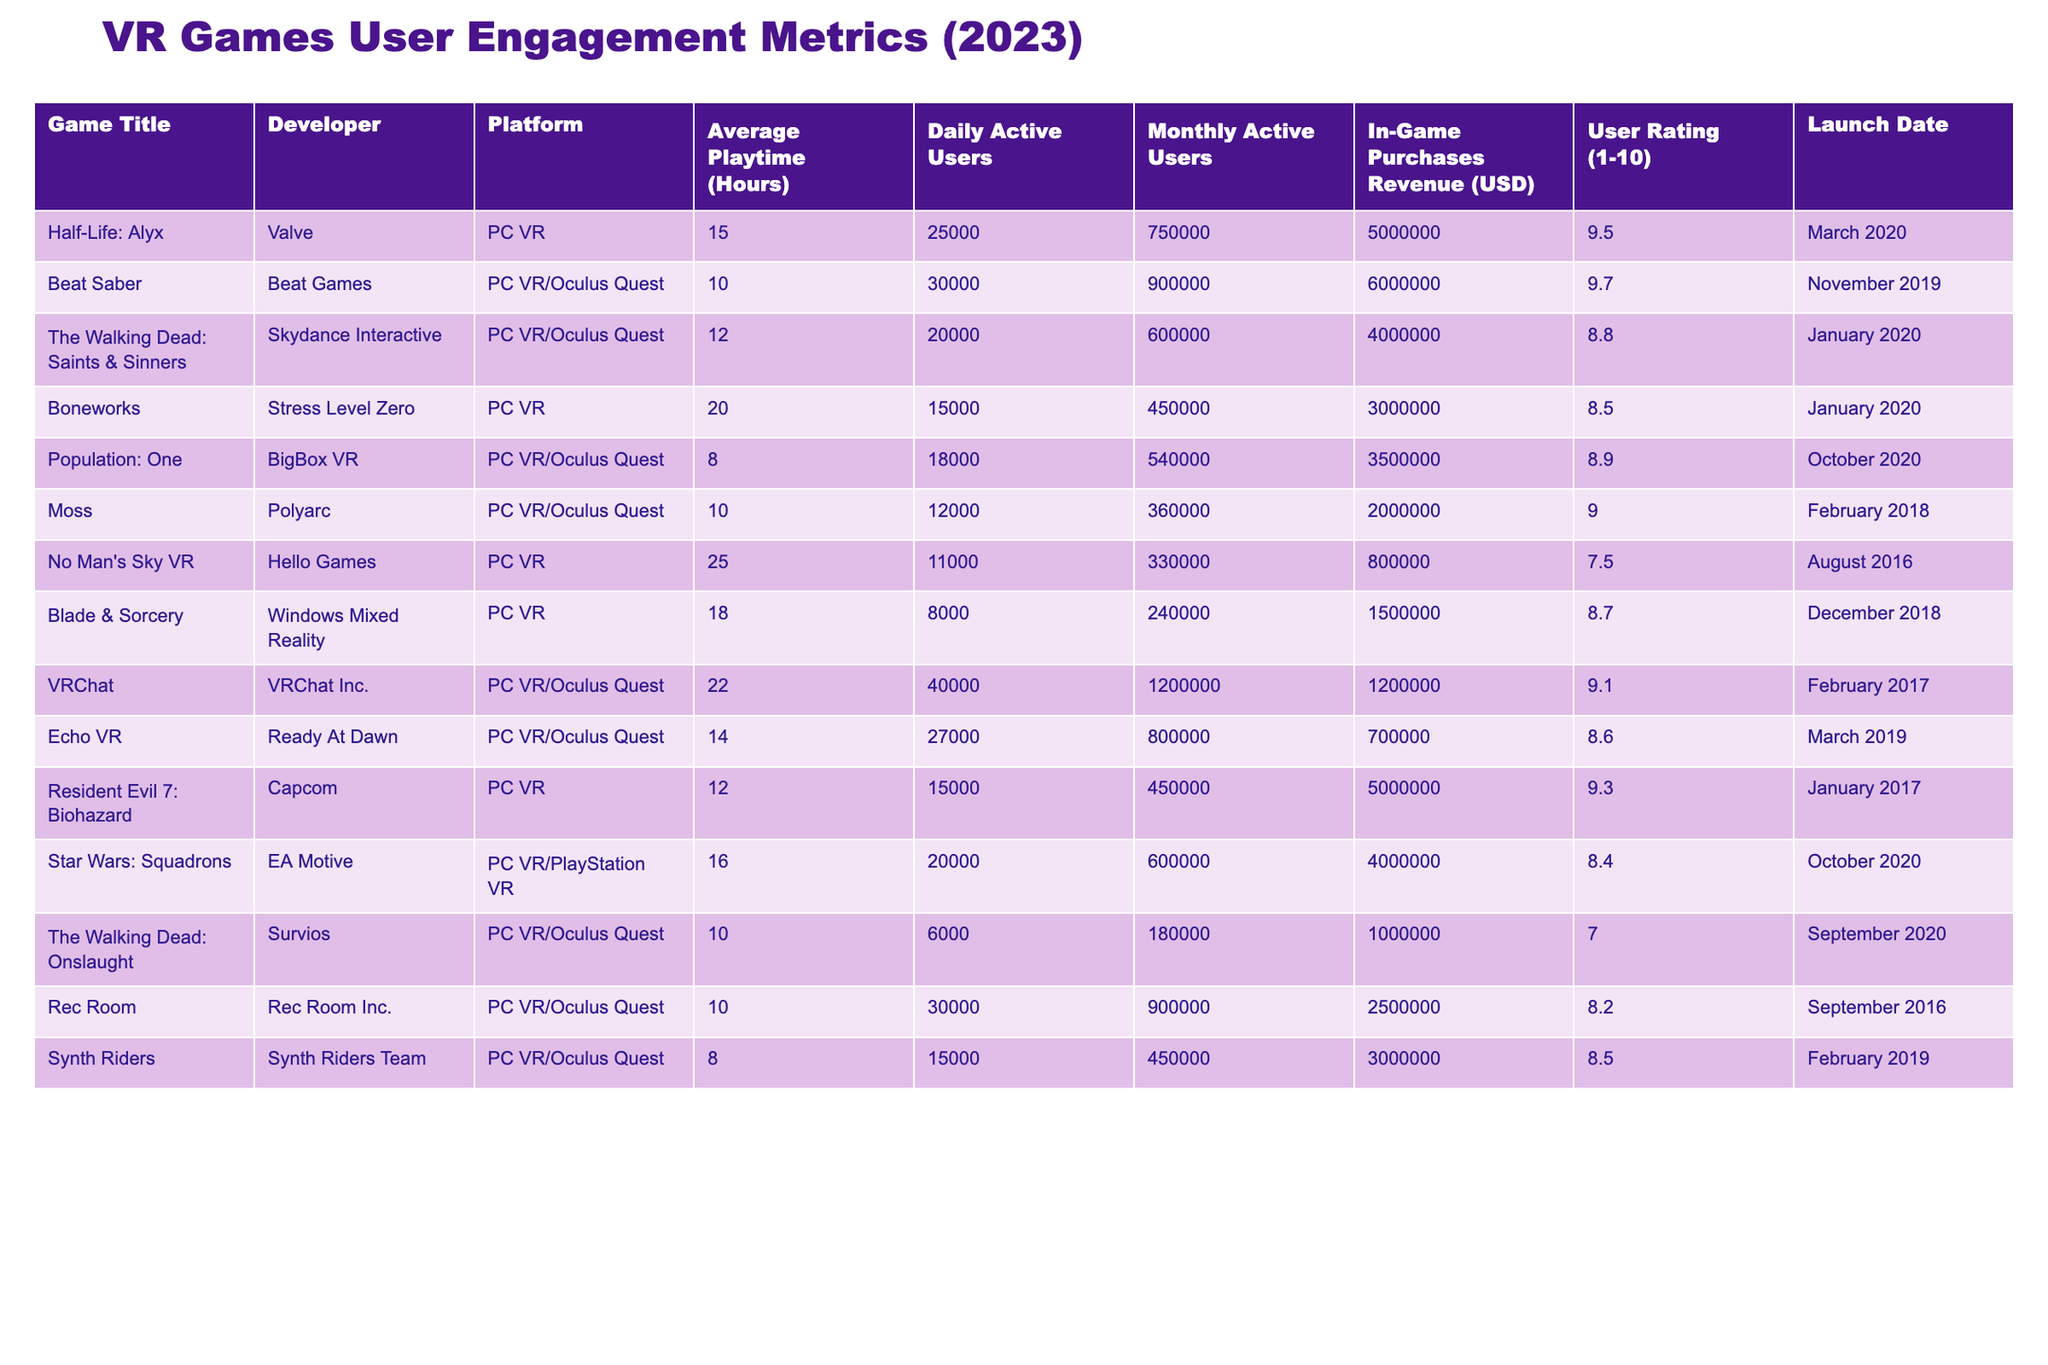What is the highest user rating among the VR games listed? The user ratings from the table show the highest value is 9.7 for Beat Saber.
Answer: 9.7 Which game has the lowest in-game purchases revenue? Comparing the in-game purchases revenue, The Walking Dead: Onslaught has the lowest revenue at 1,000,000 USD.
Answer: 1,000,000 USD What is the total monthly active users for all games combined? By adding the monthly active users for each game (750,000 + 900,000 + 600,000 + 450,000 + 540,000 + 360,000 + 330,000 + 240,000 + 1,200,000 + 800,000 + 450,000 + 600,000 + 180,000 + 900,000 + 450,000), the total is 6,687,000.
Answer: 6,687,000 Is the average playtime of No Man's Sky VR greater than the average playtime of VRChat? The average playtime for No Man's Sky VR is 25 hours, while VRChat has an average playtime of 22 hours. Since 25 is greater than 22, the statement is true.
Answer: Yes Which game has the highest average playtime and what is its value? The highest average playtime is 25 hours for No Man's Sky VR.
Answer: 25 hours Are there more daily active users in Beat Saber or in Boneworks? Beat Saber has 30,000 daily active users, while Boneworks has 15,000. Since 30,000 is greater than 15,000, Beat Saber has more daily active users.
Answer: Beat Saber What is the difference in monthly active users between Echo VR and The Walking Dead: Onslaught? Echo VR has 800,000 monthly active users and The Walking Dead: Onslaught has 180,000. The difference is 800,000 - 180,000 = 620,000.
Answer: 620,000 Which game has a higher in-game purchases revenue, Blade & Sorcery or The Walking Dead: Saints & Sinners? Blade & Sorcery has 1,500,000 USD in revenue while The Walking Dead: Saints & Sinners has 4,000,000 USD. Since 4,000,000 is greater than 1,500,000, The Walking Dead: Saints & Sinners has higher revenue.
Answer: The Walking Dead: Saints & Sinners What percentage of the total in-game purchases revenue do the top three games make? The top three games are Beat Saber (6,000,000), Half-Life: Alyx (5,000,000), and The Walking Dead: Saints & Sinners (4,000,000), which total 15,000,000. The overall revenue from all games is 30,000,000. Thus, the percentage is (15,000,000 / 30,000,000) * 100% = 50%.
Answer: 50% Which game was launched first: Resident Evil 7: Biohazard or Echo VR? Resident Evil 7: Biohazard was launched in January 2017, and Echo VR was launched in March 2019. Therefore, Resident Evil 7: Biohazard was launched first.
Answer: Resident Evil 7: Biohazard How many games have an average playtime of less than 10 hours? The games with an average playtime less than 10 hours are Population: One (8), Synth Riders (8), and The Walking Dead: Onslaught (10). Only The Walking Dead: Onslaught is 10, so there are two games less than 10 hours.
Answer: 2 